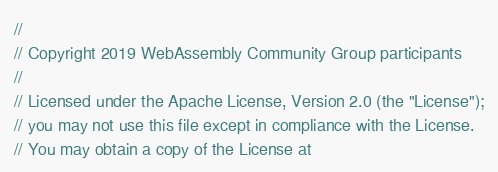<code> <loc_0><loc_0><loc_500><loc_500><_C++_>//
// Copyright 2019 WebAssembly Community Group participants
//
// Licensed under the Apache License, Version 2.0 (the "License");
// you may not use this file except in compliance with the License.
// You may obtain a copy of the License at</code> 